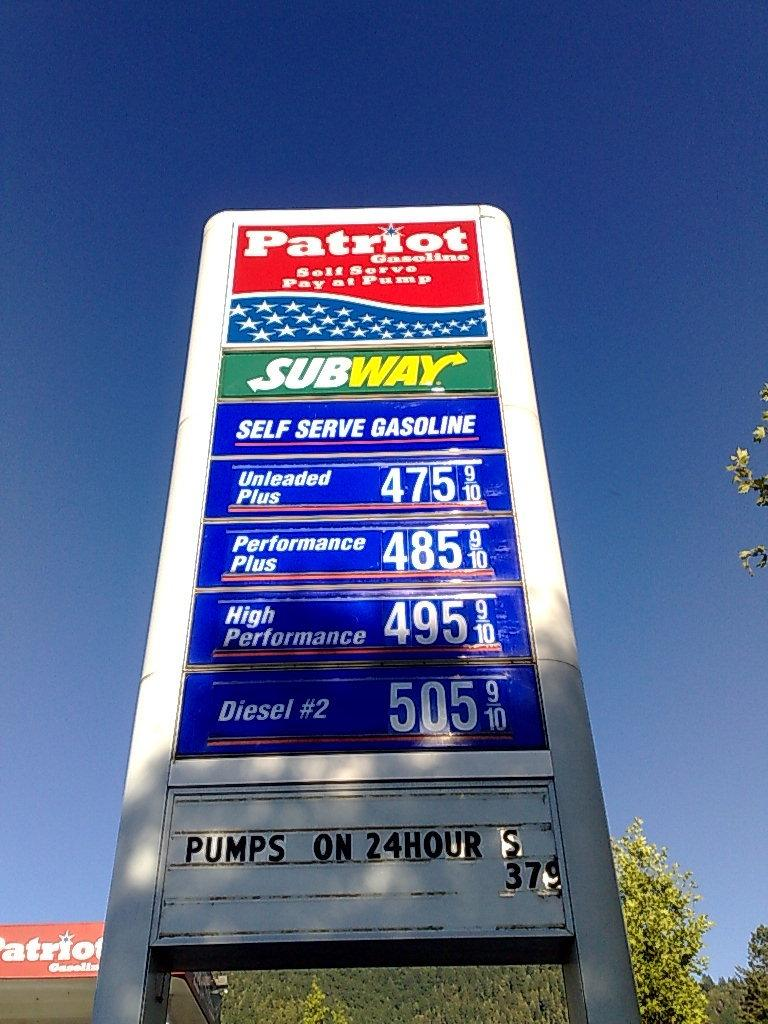<image>
Create a compact narrative representing the image presented. Patriot Gas Station that Pumps on 24 hours and has a Subway restaurant inside. 